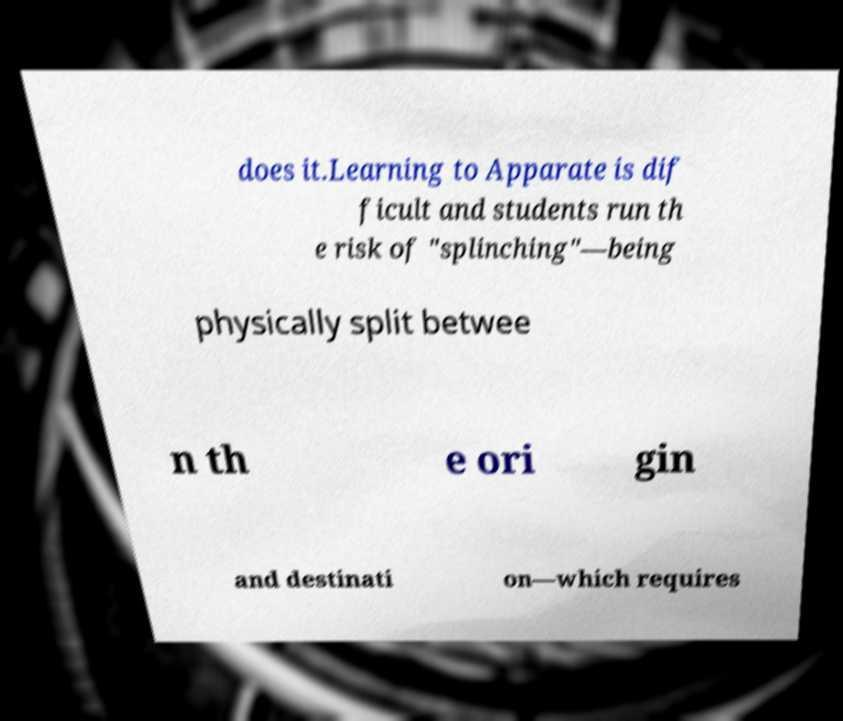Could you extract and type out the text from this image? does it.Learning to Apparate is dif ficult and students run th e risk of "splinching"—being physically split betwee n th e ori gin and destinati on—which requires 